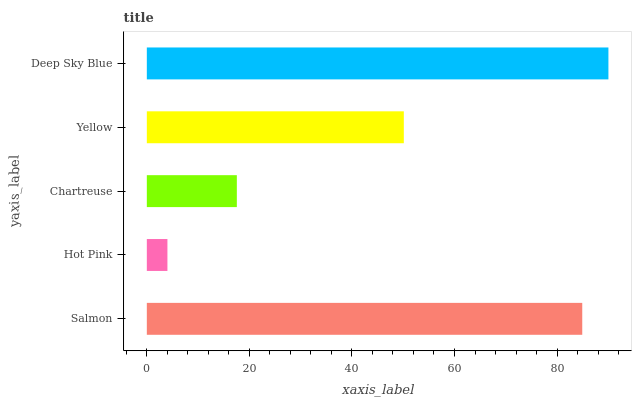Is Hot Pink the minimum?
Answer yes or no. Yes. Is Deep Sky Blue the maximum?
Answer yes or no. Yes. Is Chartreuse the minimum?
Answer yes or no. No. Is Chartreuse the maximum?
Answer yes or no. No. Is Chartreuse greater than Hot Pink?
Answer yes or no. Yes. Is Hot Pink less than Chartreuse?
Answer yes or no. Yes. Is Hot Pink greater than Chartreuse?
Answer yes or no. No. Is Chartreuse less than Hot Pink?
Answer yes or no. No. Is Yellow the high median?
Answer yes or no. Yes. Is Yellow the low median?
Answer yes or no. Yes. Is Deep Sky Blue the high median?
Answer yes or no. No. Is Deep Sky Blue the low median?
Answer yes or no. No. 